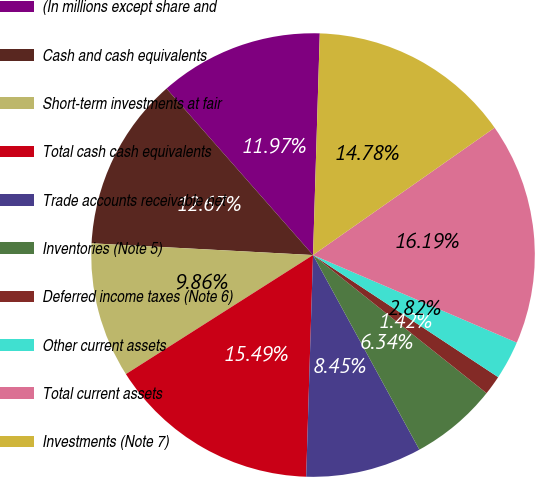<chart> <loc_0><loc_0><loc_500><loc_500><pie_chart><fcel>(In millions except share and<fcel>Cash and cash equivalents<fcel>Short-term investments at fair<fcel>Total cash cash equivalents<fcel>Trade accounts receivable net<fcel>Inventories (Note 5)<fcel>Deferred income taxes (Note 6)<fcel>Other current assets<fcel>Total current assets<fcel>Investments (Note 7)<nl><fcel>11.97%<fcel>12.67%<fcel>9.86%<fcel>15.49%<fcel>8.45%<fcel>6.34%<fcel>1.42%<fcel>2.82%<fcel>16.19%<fcel>14.78%<nl></chart> 